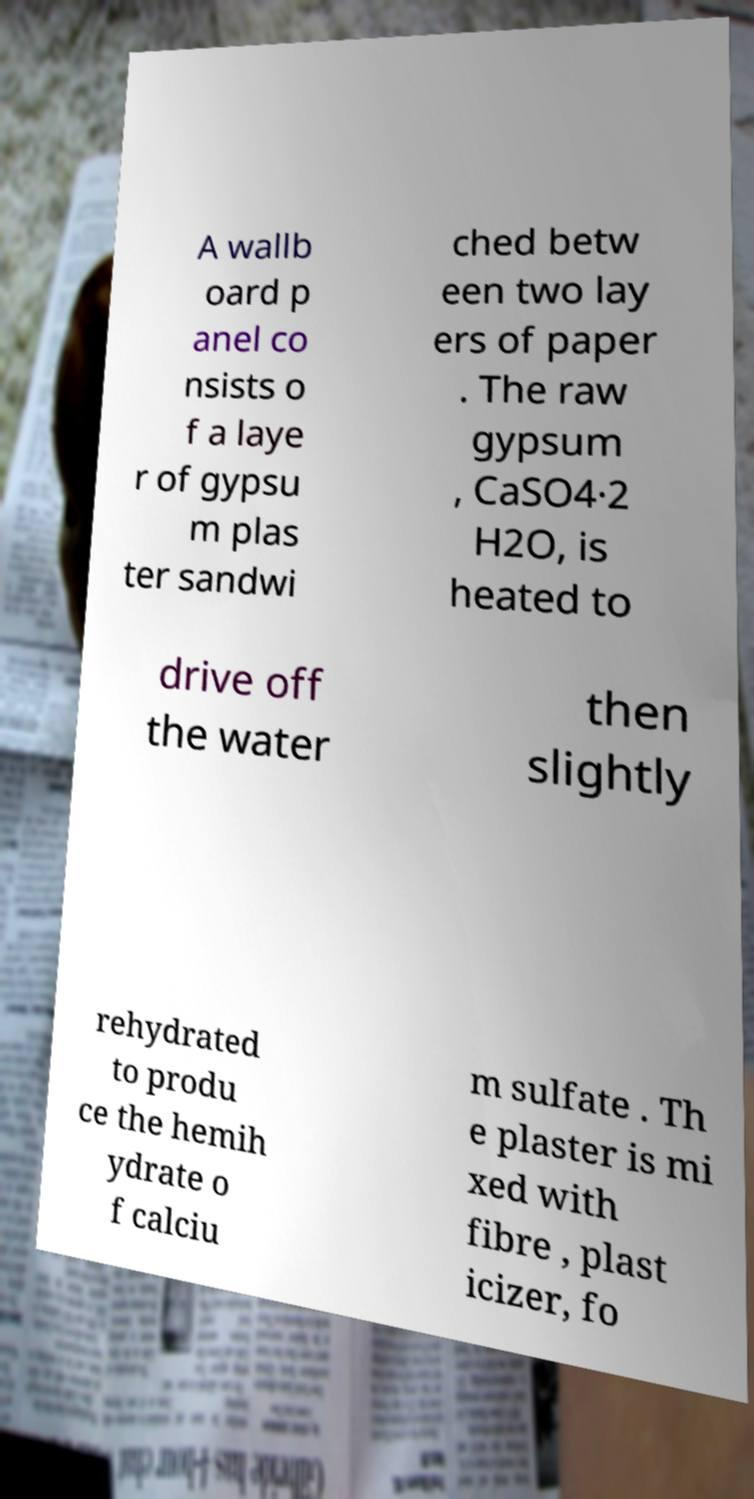Could you assist in decoding the text presented in this image and type it out clearly? A wallb oard p anel co nsists o f a laye r of gypsu m plas ter sandwi ched betw een two lay ers of paper . The raw gypsum , CaSO4·2 H2O, is heated to drive off the water then slightly rehydrated to produ ce the hemih ydrate o f calciu m sulfate . Th e plaster is mi xed with fibre , plast icizer, fo 